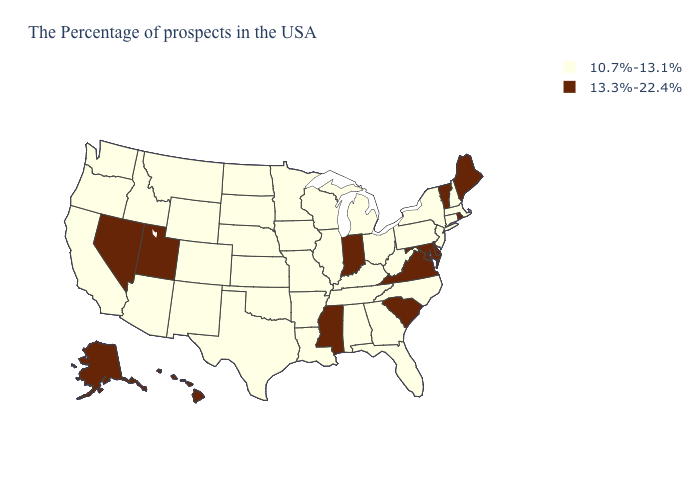Name the states that have a value in the range 10.7%-13.1%?
Concise answer only. Massachusetts, New Hampshire, Connecticut, New York, New Jersey, Pennsylvania, North Carolina, West Virginia, Ohio, Florida, Georgia, Michigan, Kentucky, Alabama, Tennessee, Wisconsin, Illinois, Louisiana, Missouri, Arkansas, Minnesota, Iowa, Kansas, Nebraska, Oklahoma, Texas, South Dakota, North Dakota, Wyoming, Colorado, New Mexico, Montana, Arizona, Idaho, California, Washington, Oregon. Which states have the highest value in the USA?
Quick response, please. Maine, Rhode Island, Vermont, Delaware, Maryland, Virginia, South Carolina, Indiana, Mississippi, Utah, Nevada, Alaska, Hawaii. What is the value of Rhode Island?
Answer briefly. 13.3%-22.4%. Among the states that border Nevada , does Arizona have the lowest value?
Write a very short answer. Yes. Does Massachusetts have a lower value than South Dakota?
Write a very short answer. No. Name the states that have a value in the range 13.3%-22.4%?
Concise answer only. Maine, Rhode Island, Vermont, Delaware, Maryland, Virginia, South Carolina, Indiana, Mississippi, Utah, Nevada, Alaska, Hawaii. Which states have the lowest value in the USA?
Short answer required. Massachusetts, New Hampshire, Connecticut, New York, New Jersey, Pennsylvania, North Carolina, West Virginia, Ohio, Florida, Georgia, Michigan, Kentucky, Alabama, Tennessee, Wisconsin, Illinois, Louisiana, Missouri, Arkansas, Minnesota, Iowa, Kansas, Nebraska, Oklahoma, Texas, South Dakota, North Dakota, Wyoming, Colorado, New Mexico, Montana, Arizona, Idaho, California, Washington, Oregon. What is the lowest value in the USA?
Write a very short answer. 10.7%-13.1%. Does Connecticut have the highest value in the Northeast?
Be succinct. No. Does the map have missing data?
Give a very brief answer. No. Which states have the highest value in the USA?
Write a very short answer. Maine, Rhode Island, Vermont, Delaware, Maryland, Virginia, South Carolina, Indiana, Mississippi, Utah, Nevada, Alaska, Hawaii. Does South Carolina have the lowest value in the USA?
Be succinct. No. Is the legend a continuous bar?
Be succinct. No. 